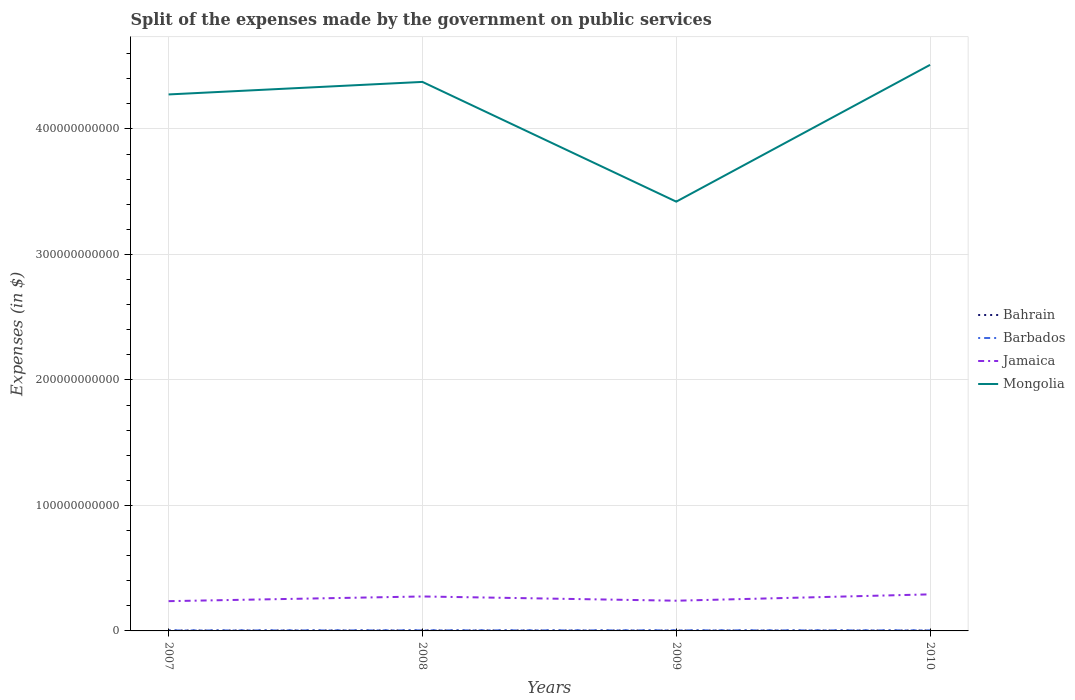Across all years, what is the maximum expenses made by the government on public services in Barbados?
Provide a short and direct response. 3.67e+08. In which year was the expenses made by the government on public services in Bahrain maximum?
Your answer should be compact. 2009. What is the total expenses made by the government on public services in Mongolia in the graph?
Offer a terse response. 9.54e+1. What is the difference between the highest and the second highest expenses made by the government on public services in Mongolia?
Provide a short and direct response. 1.09e+11. What is the difference between the highest and the lowest expenses made by the government on public services in Mongolia?
Offer a terse response. 3. Is the expenses made by the government on public services in Jamaica strictly greater than the expenses made by the government on public services in Mongolia over the years?
Make the answer very short. Yes. How many lines are there?
Keep it short and to the point. 4. What is the difference between two consecutive major ticks on the Y-axis?
Offer a very short reply. 1.00e+11. Does the graph contain any zero values?
Your response must be concise. No. Where does the legend appear in the graph?
Provide a short and direct response. Center right. How are the legend labels stacked?
Your answer should be very brief. Vertical. What is the title of the graph?
Give a very brief answer. Split of the expenses made by the government on public services. What is the label or title of the X-axis?
Offer a very short reply. Years. What is the label or title of the Y-axis?
Keep it short and to the point. Expenses (in $). What is the Expenses (in $) in Bahrain in 2007?
Offer a terse response. 3.39e+08. What is the Expenses (in $) in Barbados in 2007?
Make the answer very short. 3.67e+08. What is the Expenses (in $) in Jamaica in 2007?
Make the answer very short. 2.37e+1. What is the Expenses (in $) in Mongolia in 2007?
Give a very brief answer. 4.27e+11. What is the Expenses (in $) in Bahrain in 2008?
Keep it short and to the point. 3.96e+08. What is the Expenses (in $) in Barbados in 2008?
Keep it short and to the point. 4.35e+08. What is the Expenses (in $) of Jamaica in 2008?
Your answer should be compact. 2.75e+1. What is the Expenses (in $) in Mongolia in 2008?
Provide a succinct answer. 4.37e+11. What is the Expenses (in $) in Bahrain in 2009?
Ensure brevity in your answer.  3.18e+08. What is the Expenses (in $) in Barbados in 2009?
Ensure brevity in your answer.  4.44e+08. What is the Expenses (in $) in Jamaica in 2009?
Your response must be concise. 2.41e+1. What is the Expenses (in $) in Mongolia in 2009?
Provide a succinct answer. 3.42e+11. What is the Expenses (in $) in Bahrain in 2010?
Provide a short and direct response. 3.30e+08. What is the Expenses (in $) of Barbados in 2010?
Your answer should be very brief. 4.35e+08. What is the Expenses (in $) of Jamaica in 2010?
Offer a very short reply. 2.91e+1. What is the Expenses (in $) of Mongolia in 2010?
Make the answer very short. 4.51e+11. Across all years, what is the maximum Expenses (in $) in Bahrain?
Your response must be concise. 3.96e+08. Across all years, what is the maximum Expenses (in $) of Barbados?
Make the answer very short. 4.44e+08. Across all years, what is the maximum Expenses (in $) of Jamaica?
Provide a succinct answer. 2.91e+1. Across all years, what is the maximum Expenses (in $) in Mongolia?
Keep it short and to the point. 4.51e+11. Across all years, what is the minimum Expenses (in $) in Bahrain?
Make the answer very short. 3.18e+08. Across all years, what is the minimum Expenses (in $) of Barbados?
Your response must be concise. 3.67e+08. Across all years, what is the minimum Expenses (in $) of Jamaica?
Give a very brief answer. 2.37e+1. Across all years, what is the minimum Expenses (in $) in Mongolia?
Give a very brief answer. 3.42e+11. What is the total Expenses (in $) of Bahrain in the graph?
Offer a very short reply. 1.38e+09. What is the total Expenses (in $) of Barbados in the graph?
Offer a terse response. 1.68e+09. What is the total Expenses (in $) in Jamaica in the graph?
Offer a terse response. 1.04e+11. What is the total Expenses (in $) in Mongolia in the graph?
Provide a short and direct response. 1.66e+12. What is the difference between the Expenses (in $) in Bahrain in 2007 and that in 2008?
Make the answer very short. -5.70e+07. What is the difference between the Expenses (in $) in Barbados in 2007 and that in 2008?
Offer a terse response. -6.75e+07. What is the difference between the Expenses (in $) of Jamaica in 2007 and that in 2008?
Ensure brevity in your answer.  -3.74e+09. What is the difference between the Expenses (in $) in Mongolia in 2007 and that in 2008?
Ensure brevity in your answer.  -9.99e+09. What is the difference between the Expenses (in $) of Bahrain in 2007 and that in 2009?
Make the answer very short. 2.19e+07. What is the difference between the Expenses (in $) of Barbados in 2007 and that in 2009?
Provide a short and direct response. -7.74e+07. What is the difference between the Expenses (in $) in Jamaica in 2007 and that in 2009?
Your response must be concise. -3.56e+08. What is the difference between the Expenses (in $) in Mongolia in 2007 and that in 2009?
Your answer should be compact. 8.54e+1. What is the difference between the Expenses (in $) of Bahrain in 2007 and that in 2010?
Keep it short and to the point. 9.20e+06. What is the difference between the Expenses (in $) of Barbados in 2007 and that in 2010?
Make the answer very short. -6.83e+07. What is the difference between the Expenses (in $) of Jamaica in 2007 and that in 2010?
Provide a succinct answer. -5.42e+09. What is the difference between the Expenses (in $) of Mongolia in 2007 and that in 2010?
Your answer should be compact. -2.36e+1. What is the difference between the Expenses (in $) in Bahrain in 2008 and that in 2009?
Make the answer very short. 7.90e+07. What is the difference between the Expenses (in $) in Barbados in 2008 and that in 2009?
Your response must be concise. -9.82e+06. What is the difference between the Expenses (in $) of Jamaica in 2008 and that in 2009?
Your answer should be very brief. 3.39e+09. What is the difference between the Expenses (in $) in Mongolia in 2008 and that in 2009?
Your response must be concise. 9.54e+1. What is the difference between the Expenses (in $) of Bahrain in 2008 and that in 2010?
Your answer should be compact. 6.62e+07. What is the difference between the Expenses (in $) in Barbados in 2008 and that in 2010?
Your answer should be compact. -7.51e+05. What is the difference between the Expenses (in $) in Jamaica in 2008 and that in 2010?
Keep it short and to the point. -1.67e+09. What is the difference between the Expenses (in $) in Mongolia in 2008 and that in 2010?
Your answer should be compact. -1.36e+1. What is the difference between the Expenses (in $) in Bahrain in 2009 and that in 2010?
Your answer should be compact. -1.27e+07. What is the difference between the Expenses (in $) in Barbados in 2009 and that in 2010?
Offer a terse response. 9.07e+06. What is the difference between the Expenses (in $) of Jamaica in 2009 and that in 2010?
Your answer should be compact. -5.06e+09. What is the difference between the Expenses (in $) of Mongolia in 2009 and that in 2010?
Your answer should be very brief. -1.09e+11. What is the difference between the Expenses (in $) of Bahrain in 2007 and the Expenses (in $) of Barbados in 2008?
Your response must be concise. -9.51e+07. What is the difference between the Expenses (in $) of Bahrain in 2007 and the Expenses (in $) of Jamaica in 2008?
Your answer should be compact. -2.71e+1. What is the difference between the Expenses (in $) of Bahrain in 2007 and the Expenses (in $) of Mongolia in 2008?
Your response must be concise. -4.37e+11. What is the difference between the Expenses (in $) of Barbados in 2007 and the Expenses (in $) of Jamaica in 2008?
Your answer should be compact. -2.71e+1. What is the difference between the Expenses (in $) of Barbados in 2007 and the Expenses (in $) of Mongolia in 2008?
Keep it short and to the point. -4.37e+11. What is the difference between the Expenses (in $) of Jamaica in 2007 and the Expenses (in $) of Mongolia in 2008?
Give a very brief answer. -4.14e+11. What is the difference between the Expenses (in $) of Bahrain in 2007 and the Expenses (in $) of Barbados in 2009?
Make the answer very short. -1.05e+08. What is the difference between the Expenses (in $) in Bahrain in 2007 and the Expenses (in $) in Jamaica in 2009?
Your response must be concise. -2.37e+1. What is the difference between the Expenses (in $) in Bahrain in 2007 and the Expenses (in $) in Mongolia in 2009?
Offer a very short reply. -3.42e+11. What is the difference between the Expenses (in $) in Barbados in 2007 and the Expenses (in $) in Jamaica in 2009?
Your answer should be very brief. -2.37e+1. What is the difference between the Expenses (in $) of Barbados in 2007 and the Expenses (in $) of Mongolia in 2009?
Keep it short and to the point. -3.42e+11. What is the difference between the Expenses (in $) in Jamaica in 2007 and the Expenses (in $) in Mongolia in 2009?
Offer a terse response. -3.18e+11. What is the difference between the Expenses (in $) of Bahrain in 2007 and the Expenses (in $) of Barbados in 2010?
Offer a terse response. -9.59e+07. What is the difference between the Expenses (in $) in Bahrain in 2007 and the Expenses (in $) in Jamaica in 2010?
Ensure brevity in your answer.  -2.88e+1. What is the difference between the Expenses (in $) in Bahrain in 2007 and the Expenses (in $) in Mongolia in 2010?
Provide a succinct answer. -4.51e+11. What is the difference between the Expenses (in $) in Barbados in 2007 and the Expenses (in $) in Jamaica in 2010?
Offer a terse response. -2.88e+1. What is the difference between the Expenses (in $) of Barbados in 2007 and the Expenses (in $) of Mongolia in 2010?
Ensure brevity in your answer.  -4.51e+11. What is the difference between the Expenses (in $) of Jamaica in 2007 and the Expenses (in $) of Mongolia in 2010?
Provide a short and direct response. -4.27e+11. What is the difference between the Expenses (in $) of Bahrain in 2008 and the Expenses (in $) of Barbados in 2009?
Provide a succinct answer. -4.79e+07. What is the difference between the Expenses (in $) of Bahrain in 2008 and the Expenses (in $) of Jamaica in 2009?
Provide a short and direct response. -2.37e+1. What is the difference between the Expenses (in $) of Bahrain in 2008 and the Expenses (in $) of Mongolia in 2009?
Keep it short and to the point. -3.42e+11. What is the difference between the Expenses (in $) of Barbados in 2008 and the Expenses (in $) of Jamaica in 2009?
Give a very brief answer. -2.36e+1. What is the difference between the Expenses (in $) in Barbados in 2008 and the Expenses (in $) in Mongolia in 2009?
Provide a succinct answer. -3.42e+11. What is the difference between the Expenses (in $) of Jamaica in 2008 and the Expenses (in $) of Mongolia in 2009?
Your answer should be very brief. -3.15e+11. What is the difference between the Expenses (in $) in Bahrain in 2008 and the Expenses (in $) in Barbados in 2010?
Make the answer very short. -3.88e+07. What is the difference between the Expenses (in $) in Bahrain in 2008 and the Expenses (in $) in Jamaica in 2010?
Your response must be concise. -2.87e+1. What is the difference between the Expenses (in $) of Bahrain in 2008 and the Expenses (in $) of Mongolia in 2010?
Provide a short and direct response. -4.51e+11. What is the difference between the Expenses (in $) of Barbados in 2008 and the Expenses (in $) of Jamaica in 2010?
Your answer should be compact. -2.87e+1. What is the difference between the Expenses (in $) of Barbados in 2008 and the Expenses (in $) of Mongolia in 2010?
Your answer should be compact. -4.51e+11. What is the difference between the Expenses (in $) in Jamaica in 2008 and the Expenses (in $) in Mongolia in 2010?
Offer a terse response. -4.24e+11. What is the difference between the Expenses (in $) in Bahrain in 2009 and the Expenses (in $) in Barbados in 2010?
Make the answer very short. -1.18e+08. What is the difference between the Expenses (in $) of Bahrain in 2009 and the Expenses (in $) of Jamaica in 2010?
Make the answer very short. -2.88e+1. What is the difference between the Expenses (in $) in Bahrain in 2009 and the Expenses (in $) in Mongolia in 2010?
Your answer should be compact. -4.51e+11. What is the difference between the Expenses (in $) in Barbados in 2009 and the Expenses (in $) in Jamaica in 2010?
Provide a short and direct response. -2.87e+1. What is the difference between the Expenses (in $) of Barbados in 2009 and the Expenses (in $) of Mongolia in 2010?
Give a very brief answer. -4.51e+11. What is the difference between the Expenses (in $) of Jamaica in 2009 and the Expenses (in $) of Mongolia in 2010?
Your response must be concise. -4.27e+11. What is the average Expenses (in $) in Bahrain per year?
Provide a short and direct response. 3.46e+08. What is the average Expenses (in $) of Barbados per year?
Offer a terse response. 4.20e+08. What is the average Expenses (in $) in Jamaica per year?
Offer a terse response. 2.61e+1. What is the average Expenses (in $) of Mongolia per year?
Provide a short and direct response. 4.15e+11. In the year 2007, what is the difference between the Expenses (in $) of Bahrain and Expenses (in $) of Barbados?
Ensure brevity in your answer.  -2.76e+07. In the year 2007, what is the difference between the Expenses (in $) of Bahrain and Expenses (in $) of Jamaica?
Make the answer very short. -2.34e+1. In the year 2007, what is the difference between the Expenses (in $) in Bahrain and Expenses (in $) in Mongolia?
Give a very brief answer. -4.27e+11. In the year 2007, what is the difference between the Expenses (in $) of Barbados and Expenses (in $) of Jamaica?
Your answer should be very brief. -2.33e+1. In the year 2007, what is the difference between the Expenses (in $) of Barbados and Expenses (in $) of Mongolia?
Your response must be concise. -4.27e+11. In the year 2007, what is the difference between the Expenses (in $) of Jamaica and Expenses (in $) of Mongolia?
Your response must be concise. -4.04e+11. In the year 2008, what is the difference between the Expenses (in $) in Bahrain and Expenses (in $) in Barbados?
Keep it short and to the point. -3.81e+07. In the year 2008, what is the difference between the Expenses (in $) in Bahrain and Expenses (in $) in Jamaica?
Provide a short and direct response. -2.71e+1. In the year 2008, what is the difference between the Expenses (in $) of Bahrain and Expenses (in $) of Mongolia?
Provide a short and direct response. -4.37e+11. In the year 2008, what is the difference between the Expenses (in $) in Barbados and Expenses (in $) in Jamaica?
Offer a terse response. -2.70e+1. In the year 2008, what is the difference between the Expenses (in $) in Barbados and Expenses (in $) in Mongolia?
Offer a very short reply. -4.37e+11. In the year 2008, what is the difference between the Expenses (in $) of Jamaica and Expenses (in $) of Mongolia?
Your response must be concise. -4.10e+11. In the year 2009, what is the difference between the Expenses (in $) of Bahrain and Expenses (in $) of Barbados?
Make the answer very short. -1.27e+08. In the year 2009, what is the difference between the Expenses (in $) of Bahrain and Expenses (in $) of Jamaica?
Your answer should be very brief. -2.38e+1. In the year 2009, what is the difference between the Expenses (in $) in Bahrain and Expenses (in $) in Mongolia?
Make the answer very short. -3.42e+11. In the year 2009, what is the difference between the Expenses (in $) in Barbados and Expenses (in $) in Jamaica?
Offer a terse response. -2.36e+1. In the year 2009, what is the difference between the Expenses (in $) in Barbados and Expenses (in $) in Mongolia?
Your answer should be compact. -3.42e+11. In the year 2009, what is the difference between the Expenses (in $) of Jamaica and Expenses (in $) of Mongolia?
Your answer should be very brief. -3.18e+11. In the year 2010, what is the difference between the Expenses (in $) in Bahrain and Expenses (in $) in Barbados?
Offer a very short reply. -1.05e+08. In the year 2010, what is the difference between the Expenses (in $) of Bahrain and Expenses (in $) of Jamaica?
Your answer should be very brief. -2.88e+1. In the year 2010, what is the difference between the Expenses (in $) in Bahrain and Expenses (in $) in Mongolia?
Your answer should be compact. -4.51e+11. In the year 2010, what is the difference between the Expenses (in $) in Barbados and Expenses (in $) in Jamaica?
Provide a short and direct response. -2.87e+1. In the year 2010, what is the difference between the Expenses (in $) in Barbados and Expenses (in $) in Mongolia?
Provide a succinct answer. -4.51e+11. In the year 2010, what is the difference between the Expenses (in $) in Jamaica and Expenses (in $) in Mongolia?
Give a very brief answer. -4.22e+11. What is the ratio of the Expenses (in $) in Bahrain in 2007 to that in 2008?
Keep it short and to the point. 0.86. What is the ratio of the Expenses (in $) in Barbados in 2007 to that in 2008?
Offer a terse response. 0.84. What is the ratio of the Expenses (in $) of Jamaica in 2007 to that in 2008?
Keep it short and to the point. 0.86. What is the ratio of the Expenses (in $) of Mongolia in 2007 to that in 2008?
Provide a short and direct response. 0.98. What is the ratio of the Expenses (in $) in Bahrain in 2007 to that in 2009?
Provide a short and direct response. 1.07. What is the ratio of the Expenses (in $) of Barbados in 2007 to that in 2009?
Make the answer very short. 0.83. What is the ratio of the Expenses (in $) of Jamaica in 2007 to that in 2009?
Provide a short and direct response. 0.99. What is the ratio of the Expenses (in $) of Mongolia in 2007 to that in 2009?
Your answer should be very brief. 1.25. What is the ratio of the Expenses (in $) of Bahrain in 2007 to that in 2010?
Give a very brief answer. 1.03. What is the ratio of the Expenses (in $) of Barbados in 2007 to that in 2010?
Offer a very short reply. 0.84. What is the ratio of the Expenses (in $) of Jamaica in 2007 to that in 2010?
Your response must be concise. 0.81. What is the ratio of the Expenses (in $) of Mongolia in 2007 to that in 2010?
Offer a terse response. 0.95. What is the ratio of the Expenses (in $) in Bahrain in 2008 to that in 2009?
Provide a short and direct response. 1.25. What is the ratio of the Expenses (in $) in Barbados in 2008 to that in 2009?
Keep it short and to the point. 0.98. What is the ratio of the Expenses (in $) in Jamaica in 2008 to that in 2009?
Offer a very short reply. 1.14. What is the ratio of the Expenses (in $) in Mongolia in 2008 to that in 2009?
Give a very brief answer. 1.28. What is the ratio of the Expenses (in $) in Bahrain in 2008 to that in 2010?
Offer a terse response. 1.2. What is the ratio of the Expenses (in $) of Barbados in 2008 to that in 2010?
Your response must be concise. 1. What is the ratio of the Expenses (in $) of Jamaica in 2008 to that in 2010?
Offer a terse response. 0.94. What is the ratio of the Expenses (in $) in Mongolia in 2008 to that in 2010?
Your answer should be compact. 0.97. What is the ratio of the Expenses (in $) in Bahrain in 2009 to that in 2010?
Your answer should be compact. 0.96. What is the ratio of the Expenses (in $) of Barbados in 2009 to that in 2010?
Provide a succinct answer. 1.02. What is the ratio of the Expenses (in $) of Jamaica in 2009 to that in 2010?
Give a very brief answer. 0.83. What is the ratio of the Expenses (in $) in Mongolia in 2009 to that in 2010?
Provide a short and direct response. 0.76. What is the difference between the highest and the second highest Expenses (in $) in Bahrain?
Offer a terse response. 5.70e+07. What is the difference between the highest and the second highest Expenses (in $) in Barbados?
Provide a short and direct response. 9.07e+06. What is the difference between the highest and the second highest Expenses (in $) of Jamaica?
Provide a succinct answer. 1.67e+09. What is the difference between the highest and the second highest Expenses (in $) in Mongolia?
Offer a terse response. 1.36e+1. What is the difference between the highest and the lowest Expenses (in $) of Bahrain?
Provide a succinct answer. 7.90e+07. What is the difference between the highest and the lowest Expenses (in $) in Barbados?
Offer a very short reply. 7.74e+07. What is the difference between the highest and the lowest Expenses (in $) in Jamaica?
Provide a short and direct response. 5.42e+09. What is the difference between the highest and the lowest Expenses (in $) in Mongolia?
Your answer should be compact. 1.09e+11. 